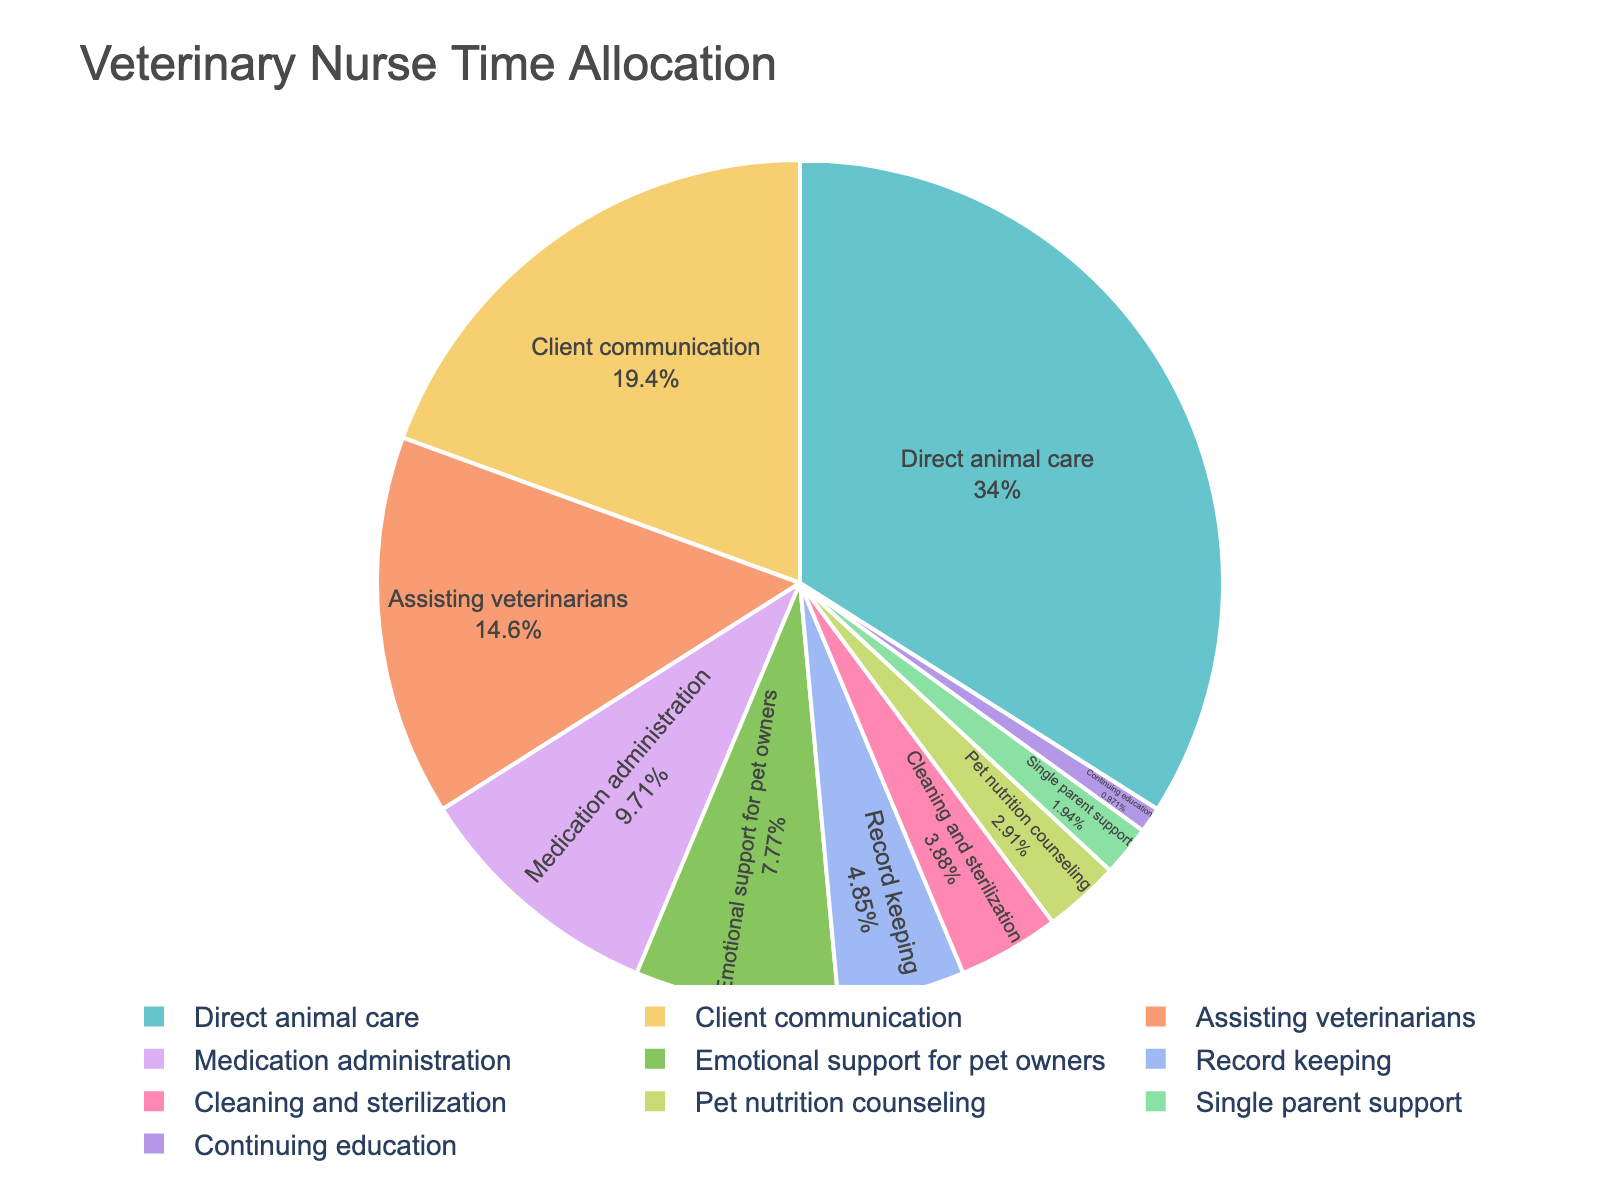Which task occupies the largest portion of the veterinary nurse's time? The visual representation shows that the 'Direct animal care' segment is the largest portion in the pie chart. Therefore, this task takes up the most time.
Answer: Direct animal care How much more time is spent on client communication compared to assisting veterinarians? From the pie chart, client communication takes 20%, and assisting veterinarians takes 15%. The difference is calculated as 20% - 15%.
Answer: 5% Which task takes the least amount of time? The segment representing 1% is the smallest on the pie chart, which corresponds to 'Continuing education'.
Answer: Continuing education What is the combined percentage of time spent on record keeping and cleaning and sterilization? The percentages for record keeping and cleaning and sterilization are 5% and 4% respectively. Summing these gives 5% + 4%.
Answer: 9% How does the time spent on medication administration compare to emotional support for pet owners? Medication administration takes up 10%, whereas emotional support for pet owners takes up 8%. Comparing these, 10% is greater than 8%.
Answer: More time is spent on medication administration Which task uses a green color on the pie chart? Visually identify the segment in green from the pie chart. This segment corresponds to the task 'Direct animal care'.
Answer: Direct animal care Among the tasks, which one is depicted with the lightest color, and what is it? The segment with the lightest color typically represents the smallest percentage. In this case, it is 'Continuing education' with 1%.
Answer: Continuing education What is the combined total percentage of time spent on all tasks related to direct animal interaction (direct animal care, medication administration, and assisting veterinarians)? The percentages for these tasks are 35%, 10%, and 15% respectively. Adding these gives 35% + 10% + 15%.
Answer: 60% If the time allocation for single parent support were doubled, what would its new percentage be? The current time allocation for single parent support is 2%. Doubling this gives 2% * 2 = 4%.
Answer: 4% What is the difference in time allocation between the most and least time-consuming tasks? The most time-consuming task, 'Direct animal care', takes 35%, and the least time-consuming task, 'Continuing education', takes 1%. The difference is 35% - 1%.
Answer: 34% 